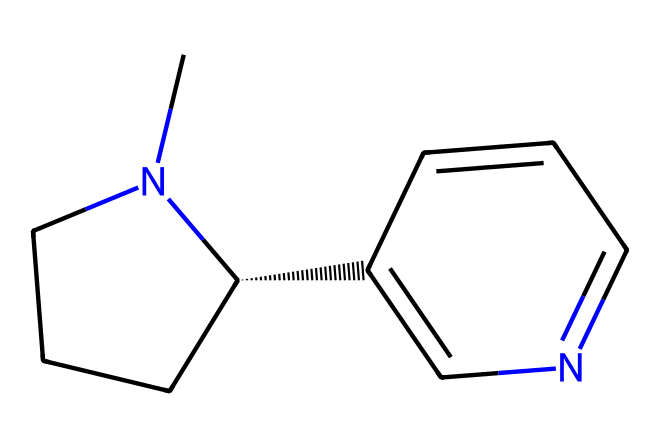What is the molecular formula of nicotine? To determine the molecular formula, we analyze the structure represented by the SMILES. Counting the carbon (C), nitrogen (N), and hydrogen (H) atoms, we find there are 10 Carbons, 14 Hydrogens, and 2 Nitrogens. Therefore, the molecular formula is C10H14N2.
Answer: C10H14N2 How many rings are present in the structure of nicotine? By examining the SMILES representation, we can identify two distinct ring structures. The notation indicates one five-membered ring and one six-membered ring within the chemical arrangement. Thus, nicotine contains two rings.
Answer: 2 What type of bonding is primarily present in nicotine? The type of bonding in the nicotine structure can be inferred from the arrangement of atoms. The presence of both single and double bonds is evident, as denoted by the connectivity between carbon and nitrogen atoms. This indicates that nicotine involves covalent bonding as the primary type of bonding.
Answer: covalent What portion of the nicotine structure contains the nitrogen atoms? Analyzing the SMILES, the nitrogen atoms are situated within the cyclic structures. The nitrogen is part of the two rings that make up the core structure of nicotine, more precisely located in the five-membered ring.
Answer: five-membered ring What is a common pharmacological effect of nicotine? Understanding the role of nicotine in pharmacology, it is known to act as a stimulant by activating nicotinic acetylcholine receptors in the nervous system. Thus, a major effect of nicotine is to enhance alertness.
Answer: alertness 